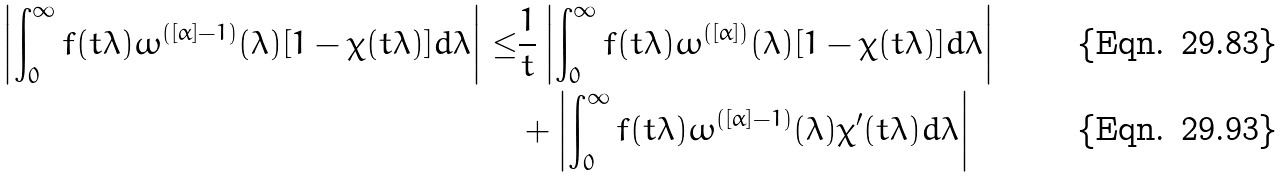Convert formula to latex. <formula><loc_0><loc_0><loc_500><loc_500>\left | \int _ { 0 } ^ { \infty } f ( t \lambda ) \omega ^ { ( [ \alpha ] - 1 ) } ( \lambda ) [ 1 - \chi ( t \lambda ) ] d \lambda \right | \leq & \frac { 1 } { t } \left | \int _ { 0 } ^ { \infty } f ( t \lambda ) \omega ^ { ( [ \alpha ] ) } ( \lambda ) [ 1 - \chi ( t \lambda ) ] d \lambda \right | \\ & + \left | \int _ { 0 } ^ { \infty } f ( t \lambda ) \omega ^ { ( [ \alpha ] - 1 ) } ( \lambda ) \chi ^ { \prime } ( t \lambda ) d \lambda \right |</formula> 